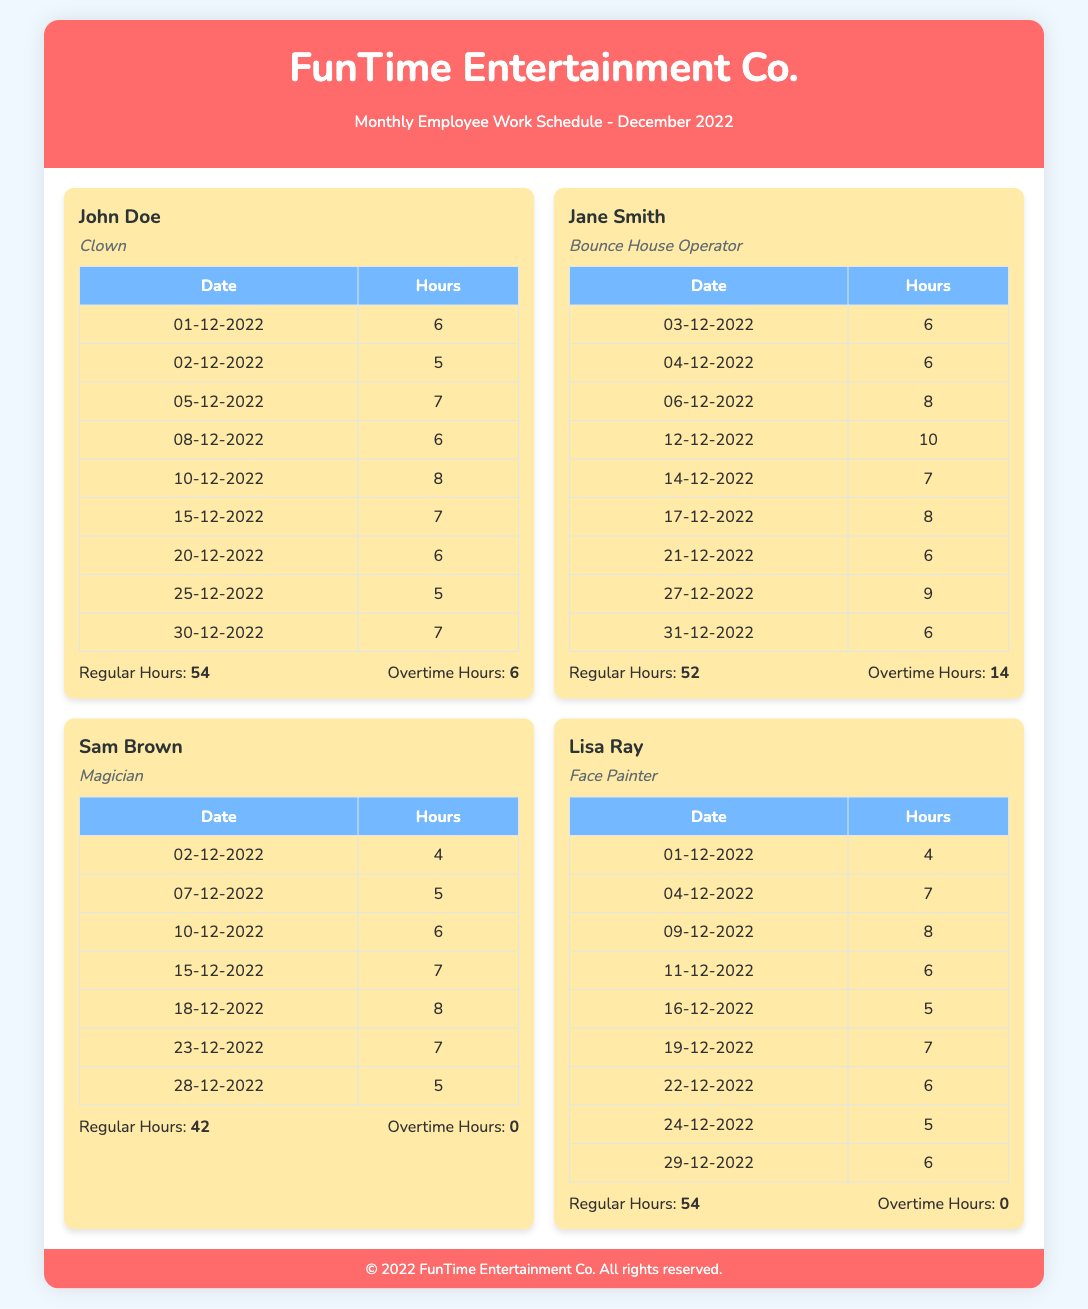What is the name of the clown? The clown's name is listed in the document, which is John Doe.
Answer: John Doe How many total hours did Jane Smith work? Jane Smith's total hours are found in the summary, which is 52 regular hours and 14 overtime hours, totaling 66 hours.
Answer: 66 What is Sam Brown's role? The role of Sam Brown is specified in the document as a magician.
Answer: Magician On what date did Lisa Ray work the most hours? The date with the most hours worked by Lisa Ray is when she worked 8 hours on 09-12-2022.
Answer: 09-12-2022 How many overtime hours did John Doe log? The document lists John Doe's overtime hours as 6, which is provided in his summary section.
Answer: 6 What is the total number of regular hours worked by all entertainers? The total regular hours can be calculated by adding John Doe's 54, Jane Smith's 52, Sam Brown's 42, and Lisa Ray's 54.
Answer: 202 Which employee worked the least hours? Sam Brown worked the least hours with a total of 42 hours according to the summary section.
Answer: 42 What is the maximum number of hours worked on a single day by any employee? The maximum hours worked on a single day is found in Jane Smith's schedule, which is 10 hours on 12-12-2022.
Answer: 10 How many entertainers recorded overtime in December 2022? The document indicates that John Doe and Jane Smith were the only entertainers with overtime, meaning 2 entertainers recorded it.
Answer: 2 